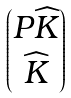Convert formula to latex. <formula><loc_0><loc_0><loc_500><loc_500>\begin{pmatrix} P \widehat { K } \\ \widehat { K } \end{pmatrix}</formula> 